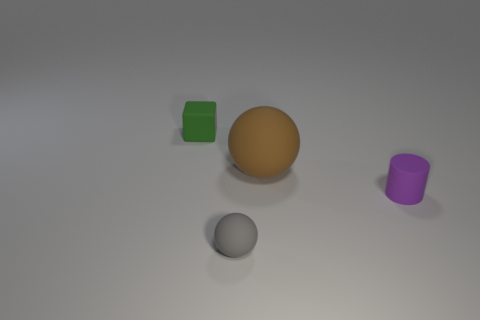How many other objects are the same shape as the purple matte object?
Keep it short and to the point. 0. There is a small ball; are there any small green rubber cubes right of it?
Your answer should be very brief. No. The rubber cylinder has what color?
Offer a very short reply. Purple. Are there any green cubes of the same size as the gray rubber sphere?
Your response must be concise. Yes. What is the small object that is behind the purple matte cylinder made of?
Your answer should be very brief. Rubber. Are there an equal number of big rubber spheres that are right of the tiny matte ball and small green matte cubes behind the rubber cube?
Offer a very short reply. No. There is a thing on the left side of the small gray matte thing; is it the same size as the matte sphere in front of the big brown matte ball?
Offer a terse response. Yes. Are there more things that are to the right of the small gray sphere than red rubber cubes?
Give a very brief answer. Yes. Do the large brown object and the small gray object have the same shape?
Provide a short and direct response. Yes. How many brown spheres are made of the same material as the tiny cylinder?
Make the answer very short. 1. 